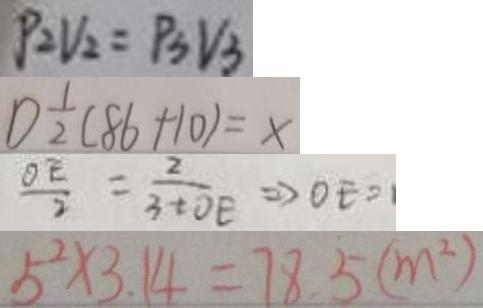<formula> <loc_0><loc_0><loc_500><loc_500>P _ { 2 } V _ { 2 } = P _ { 3 } V _ { 3 } 
 1 ) \frac { 1 } { 2 } ( 8 6 + 1 0 ) = x 
 \frac { O E } { 2 } = \frac { 2 } { 3 + O E } \Rightarrow O E = 
 5 ^ { 2 } \times 3 . 1 4 = 7 8 . 5 ( m ^ { 2 } )</formula> 